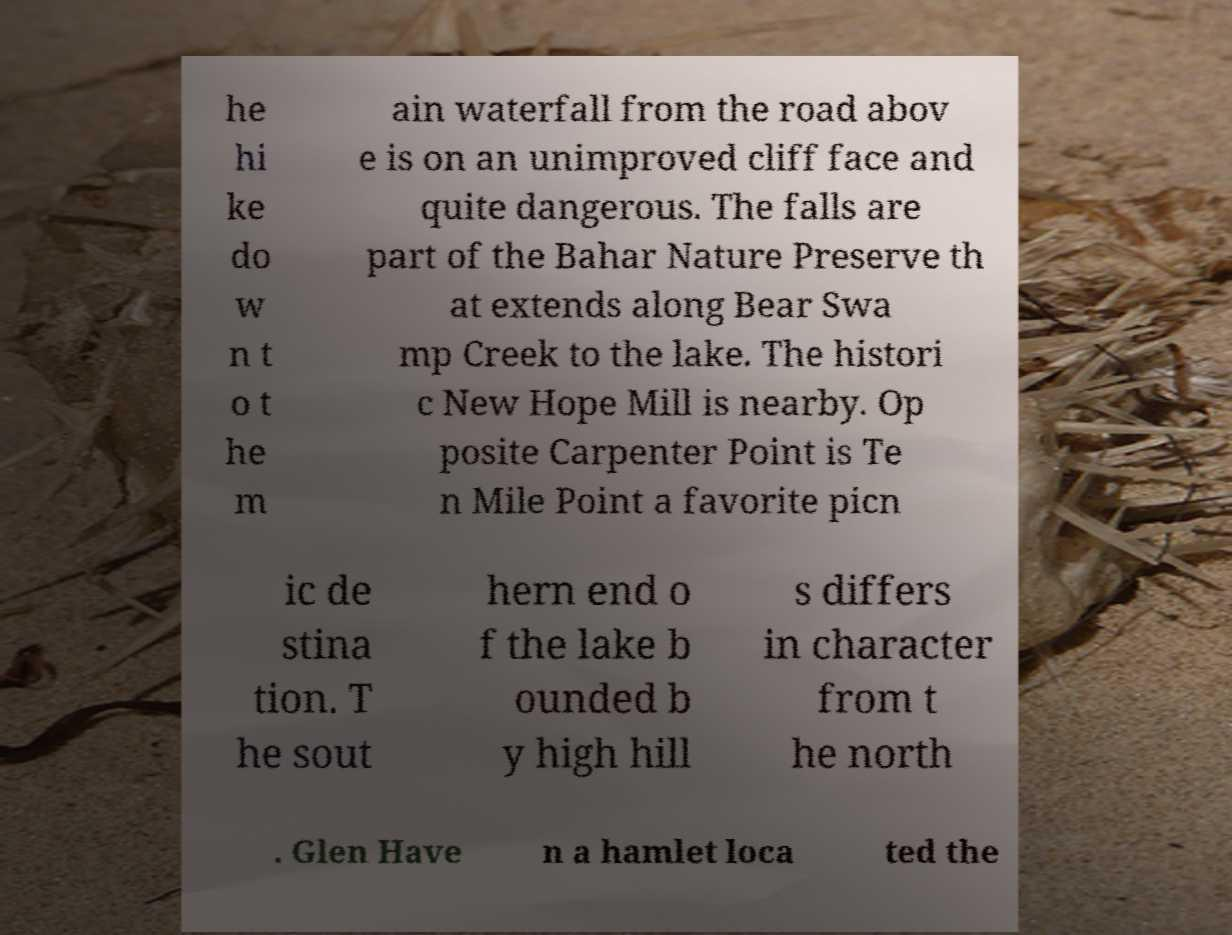Could you extract and type out the text from this image? he hi ke do w n t o t he m ain waterfall from the road abov e is on an unimproved cliff face and quite dangerous. The falls are part of the Bahar Nature Preserve th at extends along Bear Swa mp Creek to the lake. The histori c New Hope Mill is nearby. Op posite Carpenter Point is Te n Mile Point a favorite picn ic de stina tion. T he sout hern end o f the lake b ounded b y high hill s differs in character from t he north . Glen Have n a hamlet loca ted the 